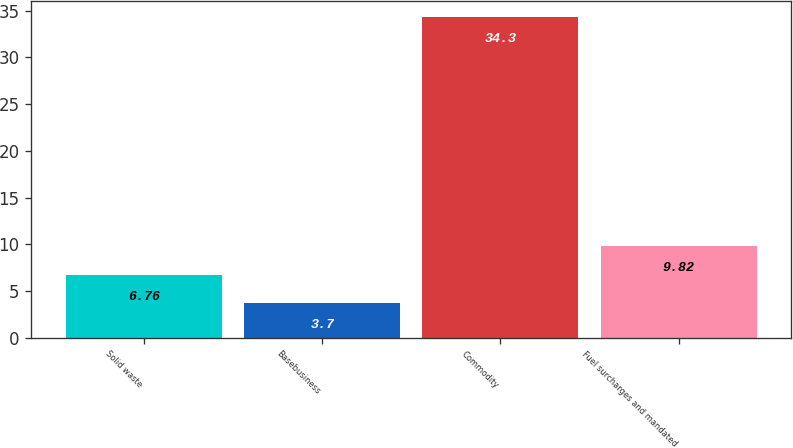Convert chart to OTSL. <chart><loc_0><loc_0><loc_500><loc_500><bar_chart><fcel>Solid waste<fcel>Basebusiness<fcel>Commodity<fcel>Fuel surcharges and mandated<nl><fcel>6.76<fcel>3.7<fcel>34.3<fcel>9.82<nl></chart> 